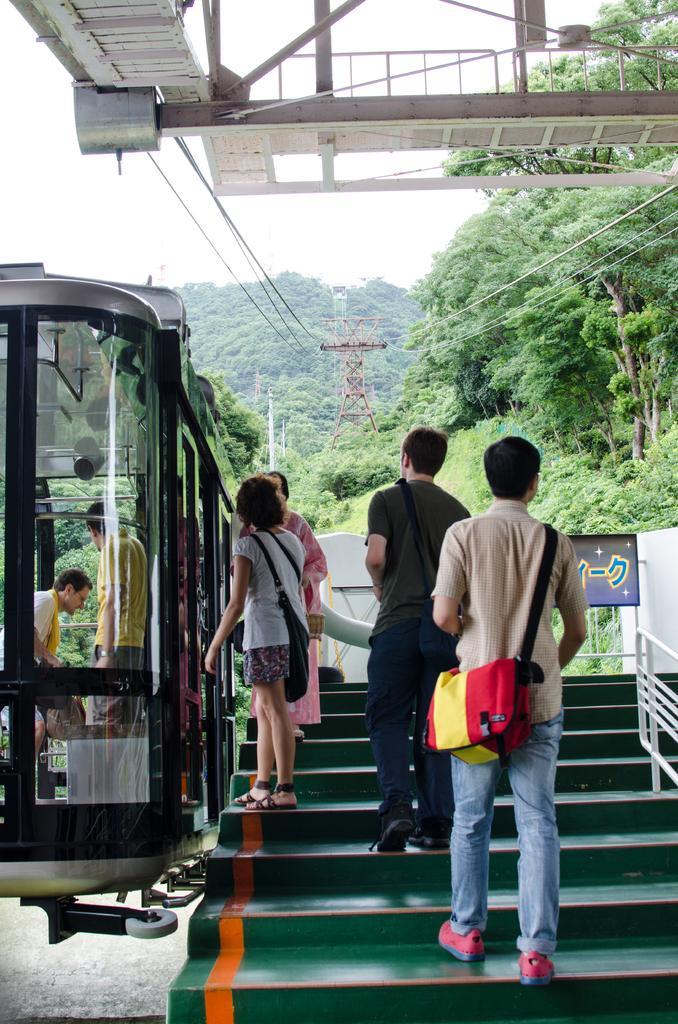Could you give a brief overview of what you see in this image? In this image I can see few people standing and few people are wearing bags. I can see few trees,cable cars,wires,towers,fencing and stairs. The sky is in white color. 